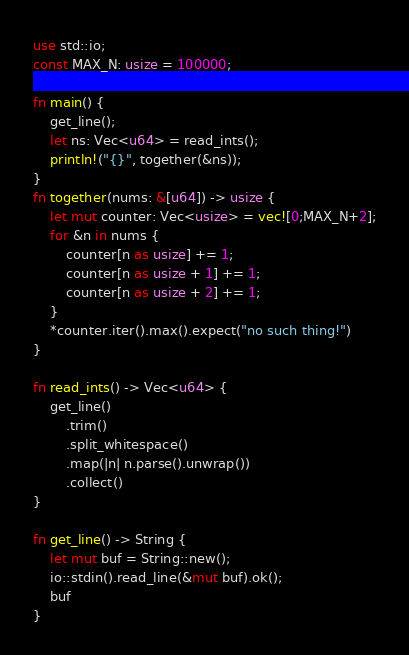Convert code to text. <code><loc_0><loc_0><loc_500><loc_500><_Rust_>use std::io;
const MAX_N: usize = 100000;

fn main() {
    get_line();
    let ns: Vec<u64> = read_ints();
    println!("{}", together(&ns));
}
fn together(nums: &[u64]) -> usize {
    let mut counter: Vec<usize> = vec![0;MAX_N+2];
    for &n in nums {
        counter[n as usize] += 1;
        counter[n as usize + 1] += 1;
        counter[n as usize + 2] += 1;
    }
    *counter.iter().max().expect("no such thing!")
}

fn read_ints() -> Vec<u64> {
    get_line()
        .trim()
        .split_whitespace()
        .map(|n| n.parse().unwrap())
        .collect()
}

fn get_line() -> String {
    let mut buf = String::new();
    io::stdin().read_line(&mut buf).ok();
    buf
}</code> 